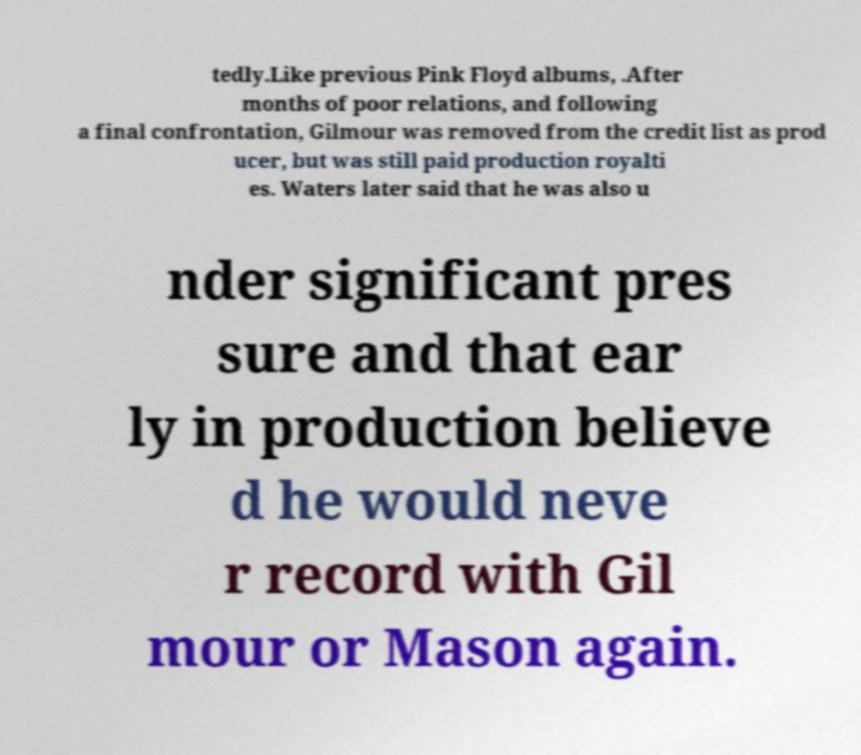There's text embedded in this image that I need extracted. Can you transcribe it verbatim? tedly.Like previous Pink Floyd albums, .After months of poor relations, and following a final confrontation, Gilmour was removed from the credit list as prod ucer, but was still paid production royalti es. Waters later said that he was also u nder significant pres sure and that ear ly in production believe d he would neve r record with Gil mour or Mason again. 